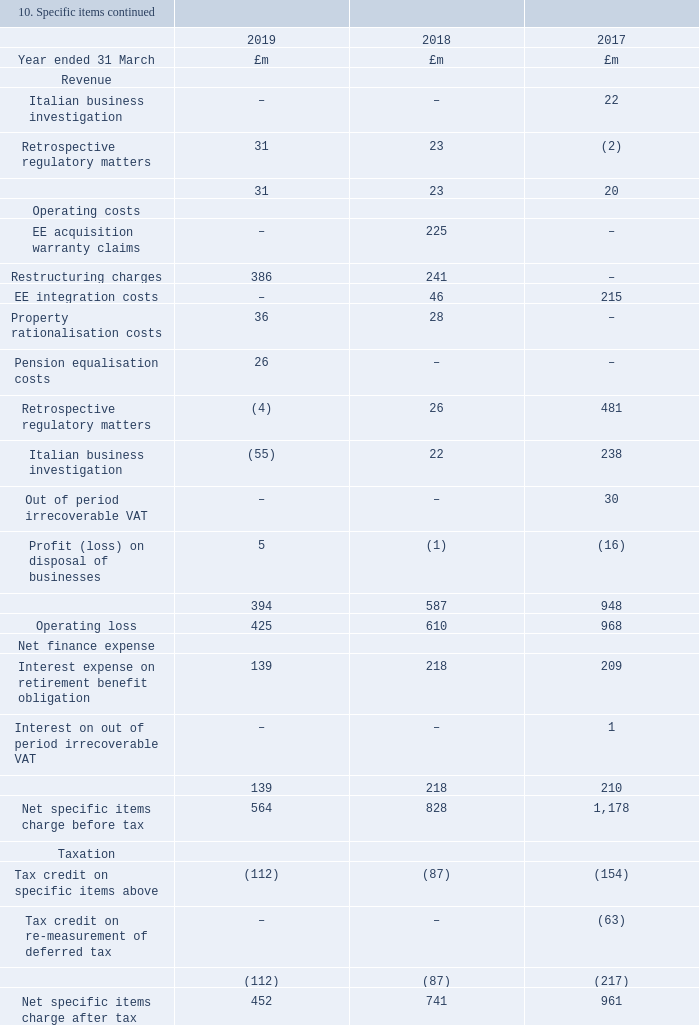Restructuring charges During the year we incurred charges of £386m (2017/18: £241m, 2016/17: £nil), primarily relating to leaver costs. These costs reflect projects within our group-wide cost transformation programme and include costs related to the remaining integration of EE and £23m costs to close the BT Pension Scheme and provide transition payments to affected employees.
EE integration costs EE integration costs incurred in prior years (2017/18: £46m, 2016/17: £215m) relate to EE related restructuring and leaver costs. In 2016/17, this also included a £62m amortisation charge relating to the write-off of IT assets as we integrated the EE and BT IT infrastructure. In the current year remaining EE integration activities have been combined into the wider restructuring programme.
Retrospective regulatory matters We have recognised a net charge of £27m (2017/18: £49m, 2016/17: £479m) in relation to regulatory matters in the year. This reflects the completion of the majority of compensation payments to other communications providers in relation to Ofcom’s March 2017 findings of its investigation into our historical practices on Deemed Consent by Openreach, and new matters arising. Of this, £31m is recognised in revenue offset by £4m in operating costs.
Pension equalisation costs During the year we recognised a charge of £26m (2017/18: £nil, 2016/17: £nil) in relation to the high court requirement to equalise pension benefits between men and women due to guaranteed minimum pension (GMP).
Property rationalisation costs We have recognised a charge of £36m (2017/18: £28m, 2016/17: £nil) relating to the rationalisation of the group’s property portfolio and a reassessment of lease-end obligations.
Italian business investigation During the year we have released £(55)m provisions relating to settlement of various matters in our Italian business (2017/18: a charge of £22m, 2016/17: a charge of £238m).
Interest expense on retirement benefit obligation During the year we incurred £139m (2017/18: £218m, 2016/17: 209m) of interest costs in relation to our defined benefit pension obligations. See note 20 for more details. Tax on specific items A tax credit of £112m (2017/18: £87m, 2016/17: 154m) was recognised in relation to specific items.
10. Specific items continued EE acquisition warranty claims In the prior year we reached settlements with Deutsche Telekom and Orange in respect of any warranty claims under the 2015 EE acquisition agreement, arising from the issues previously announced regarding our operations in Italy. This represents a full and final settlement of these issues and resulted in a specific item charge of £225m.
What were the restructuring chares in 2019? £386m. What were the EE integration costs incurred in prior years? (2017/18: £46m, 2016/17: £215m). What was the pension equilisation cost related to? High court requirement to equalise pension benefits between men and women due to guaranteed minimum pension (gmp). What is the change in the Retrospective regulatory matters from 2018 to 2019?
Answer scale should be: million. 31 - 23
Answer: 8. What is the percentage change in the Property rationalisation costs from 2018 to 2019?
Answer scale should be: percent. 36 / 28 - 1
Answer: 28.57. What is the average Restructuring charges for 2017-2019?
Answer scale should be: million. (386 + 241 + 0) / 3
Answer: 209. 